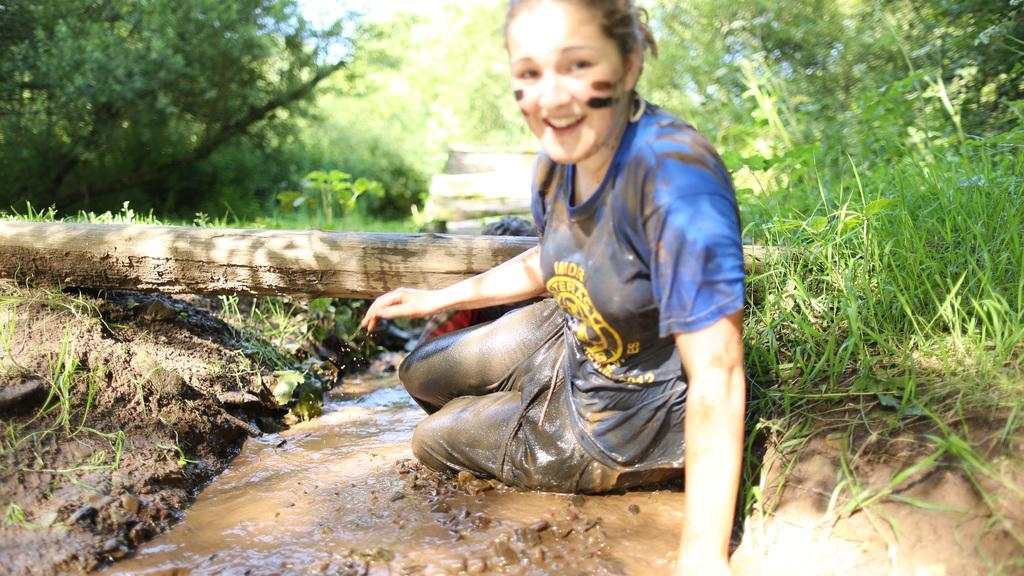Who is the main subject in the image? There is a lady in the image. What is the lady doing in the image? The lady is lying on the ground. What is the condition of the ground in the image? There is mud on the ground. What can be seen in the background of the image? There are wood, trees, grasses, and plants in the background of the image. What is the lady's expression in the image? The lady is smiling. What type of tail can be seen on the lady in the image? There is no tail present on the lady in the image. What property does the lady own in the image? The image does not provide information about the lady owning any property. 